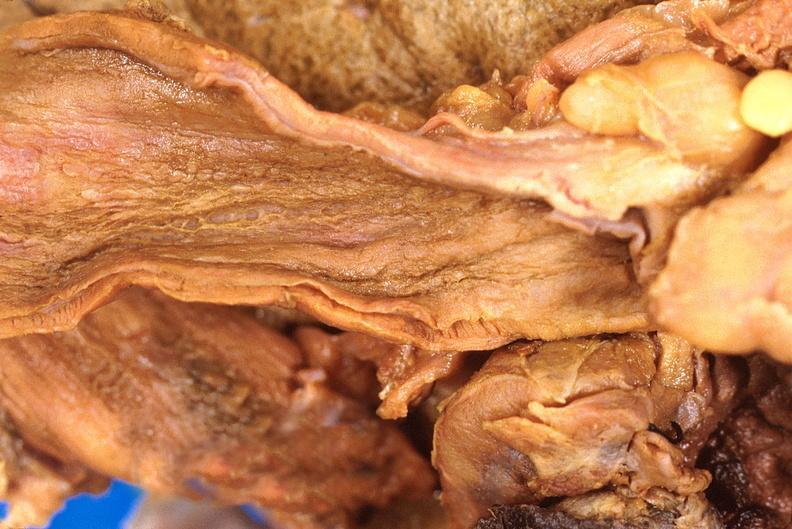what is present?
Answer the question using a single word or phrase. Gastrointestinal 